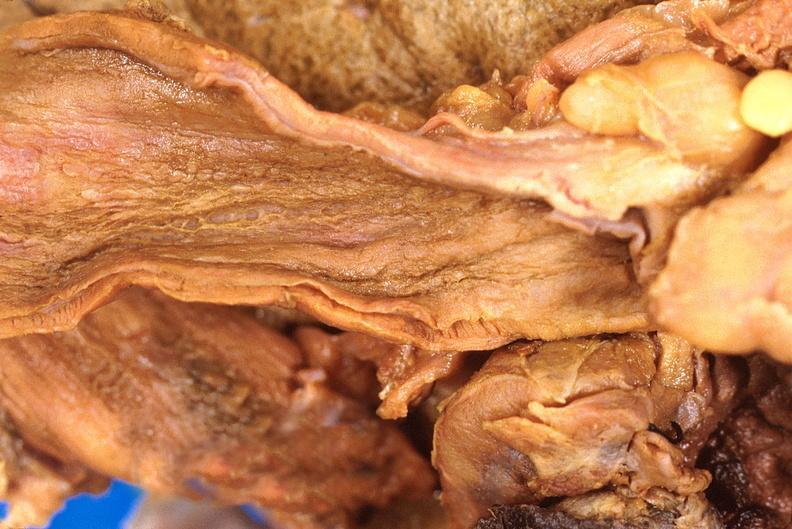what is present?
Answer the question using a single word or phrase. Gastrointestinal 